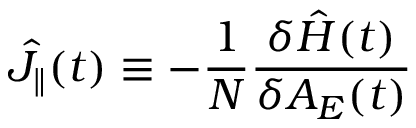<formula> <loc_0><loc_0><loc_500><loc_500>\hat { J } _ { \| } ( t ) \equiv - \frac { 1 } { N } \frac { \delta \hat { H } ( t ) } { \delta A _ { E } ( t ) }</formula> 